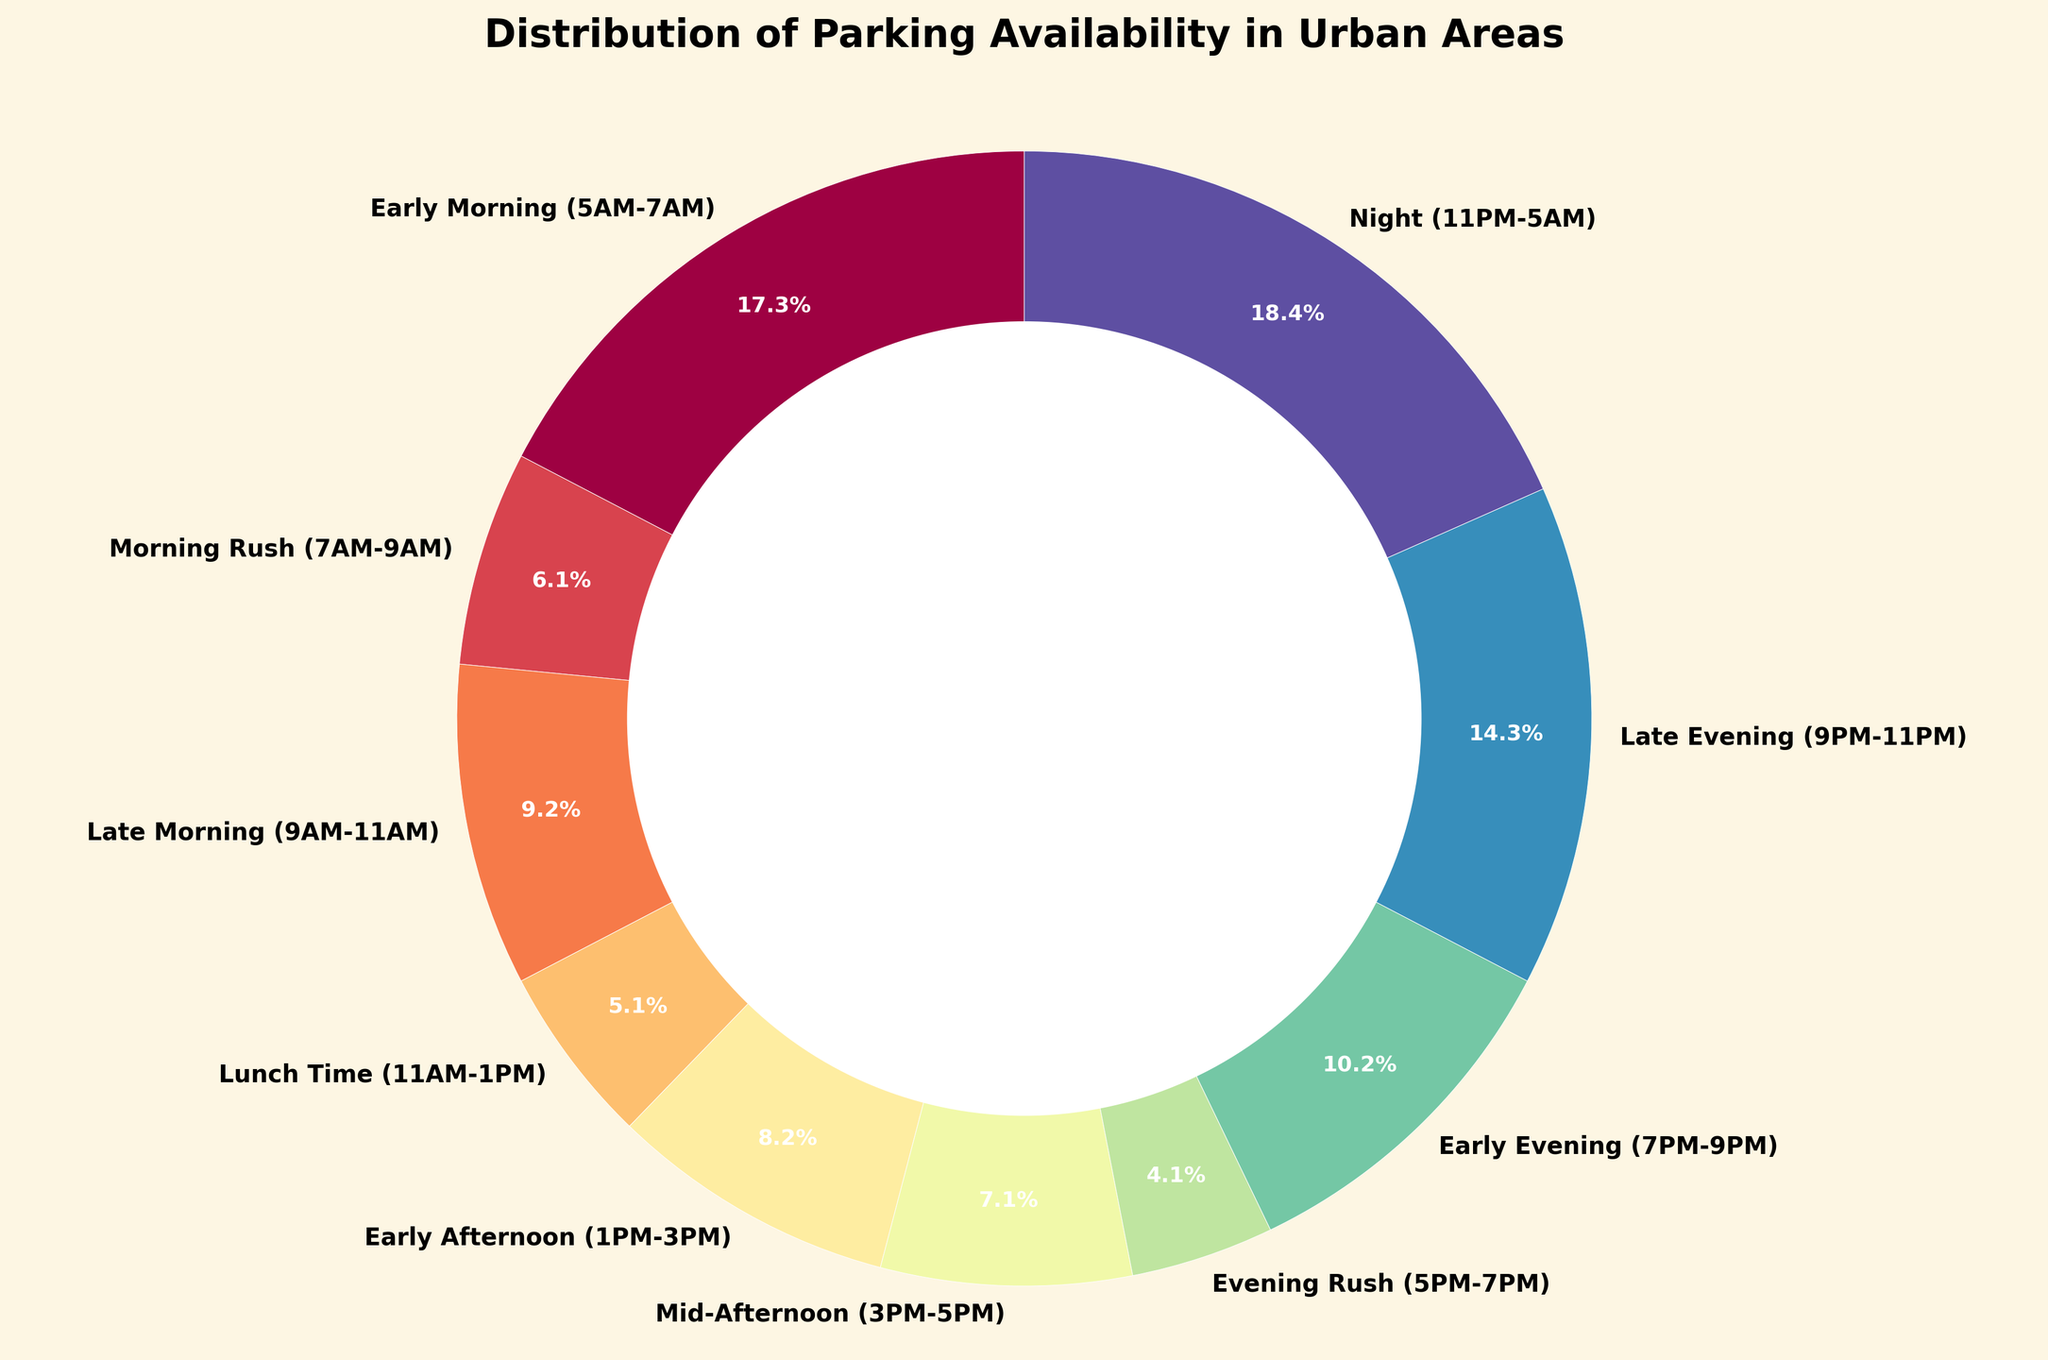Which time of day has the highest parking availability? The time of day with the largest percentage on the pie chart indicates the highest parking availability. In this case, it's the time period from Night (11PM-5AM) with 90%.
Answer: Night (11PM-5AM) Which time of day has the lowest parking availability? The time of day with the smallest percentage on the pie chart indicates the lowest parking availability. Here, it's the time period of Evening Rush (5PM-7PM) with 20%.
Answer: Evening Rush (5PM-7PM) What is the difference in parking availability between Late Morning (9AM-11AM) and Lunch Time (11AM-1PM)? Subtract the percentage of parking availability for Lunch Time from that of Late Morning: 45% - 25% = 20%.
Answer: 20% During which two consecutive time periods does parking availability increase by the greatest amount? Look at the differences in percentages between consecutive time periods and identify the largest increase. The increase from Evening Rush (20%) to Early Evening (50%) is the greatest: 50% - 20% = 30%.
Answer: Evening Rush to Early Evening Overall, what is the average parking availability percentage across the time periods? Sum all the percentages and divide by the number of time periods. The sum is (85 + 30 + 45 + 25 + 40 + 35 + 20 + 50 + 70 + 90) = 490. There are 10 time periods, so the average is 490 / 10 = 49%.
Answer: 49% How does parking availability during the Morning Rush compare to the Mid-Afternoon? Compare the percentages directly: Morning Rush (30%) is less than Mid-Afternoon (35%).
Answer: Mid-Afternoon is higher Which period has about half the parking availability of the Night (11PM-5AM) period? The Night period has 90% availability, half of this would be about 45%. The Late Morning (9AM-11AM) period fits this with 45% availability.
Answer: Late Morning (9AM-11AM) How much parking availability is there on average in the afternoon (1PM-5PM)? Average the percentages for Early Afternoon (1PM-3PM) and Mid-Afternoon (3PM-5PM): (40% + 35%) / 2 = 37.5%.
Answer: 37.5% During which part of the day (Morning, Afternoon, Evening) is parking generally more available? Morning includes Early Morning (85%), Morning Rush (30%), and Late Morning (45%). Afternoon includes Lunch Time (25%), Early Afternoon (40%), and Mid-Afternoon (35%). Evening includes Evening Rush (20%), Early Evening (50%), and Late Evening (70%). Sum these percentages and compare: Morning (85 + 30 + 45) = 160, Afternoon (25 + 40 + 35) = 100, Evening (20 + 50 + 70) = 140. Morning has the highest total availability.
Answer: Morning 